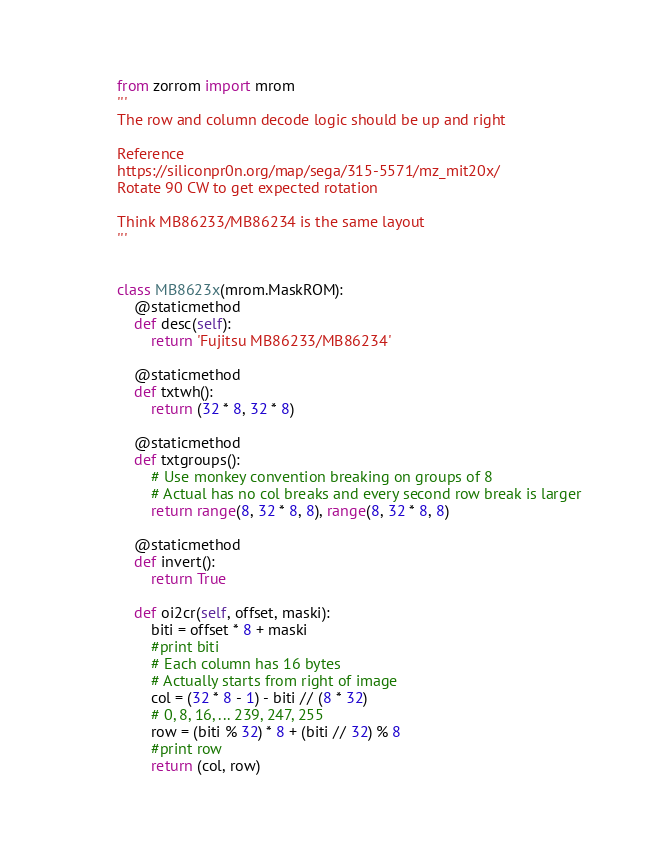<code> <loc_0><loc_0><loc_500><loc_500><_Python_>from zorrom import mrom
'''
The row and column decode logic should be up and right

Reference
https://siliconpr0n.org/map/sega/315-5571/mz_mit20x/
Rotate 90 CW to get expected rotation

Think MB86233/MB86234 is the same layout
'''


class MB8623x(mrom.MaskROM):
    @staticmethod
    def desc(self):
        return 'Fujitsu MB86233/MB86234'

    @staticmethod
    def txtwh():
        return (32 * 8, 32 * 8)

    @staticmethod
    def txtgroups():
        # Use monkey convention breaking on groups of 8
        # Actual has no col breaks and every second row break is larger
        return range(8, 32 * 8, 8), range(8, 32 * 8, 8)

    @staticmethod
    def invert():
        return True

    def oi2cr(self, offset, maski):
        biti = offset * 8 + maski
        #print biti
        # Each column has 16 bytes
        # Actually starts from right of image
        col = (32 * 8 - 1) - biti // (8 * 32)
        # 0, 8, 16, ... 239, 247, 255
        row = (biti % 32) * 8 + (biti // 32) % 8
        #print row
        return (col, row)
</code> 